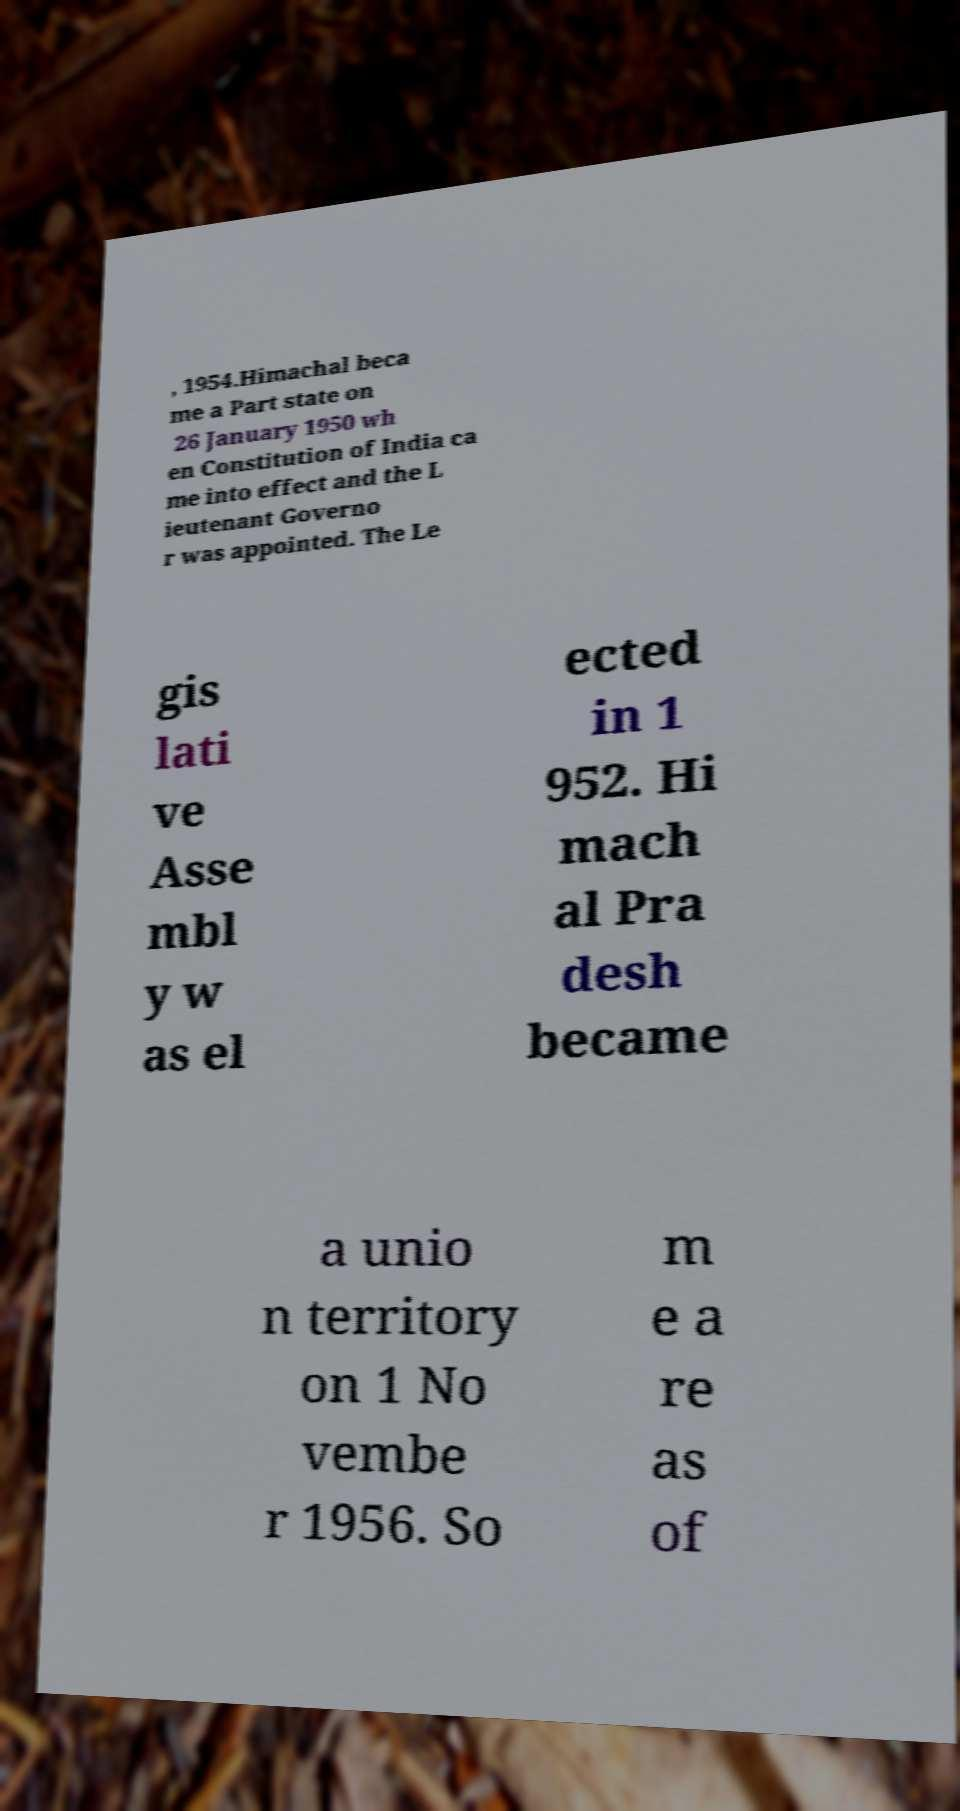Could you extract and type out the text from this image? , 1954.Himachal beca me a Part state on 26 January 1950 wh en Constitution of India ca me into effect and the L ieutenant Governo r was appointed. The Le gis lati ve Asse mbl y w as el ected in 1 952. Hi mach al Pra desh became a unio n territory on 1 No vembe r 1956. So m e a re as of 